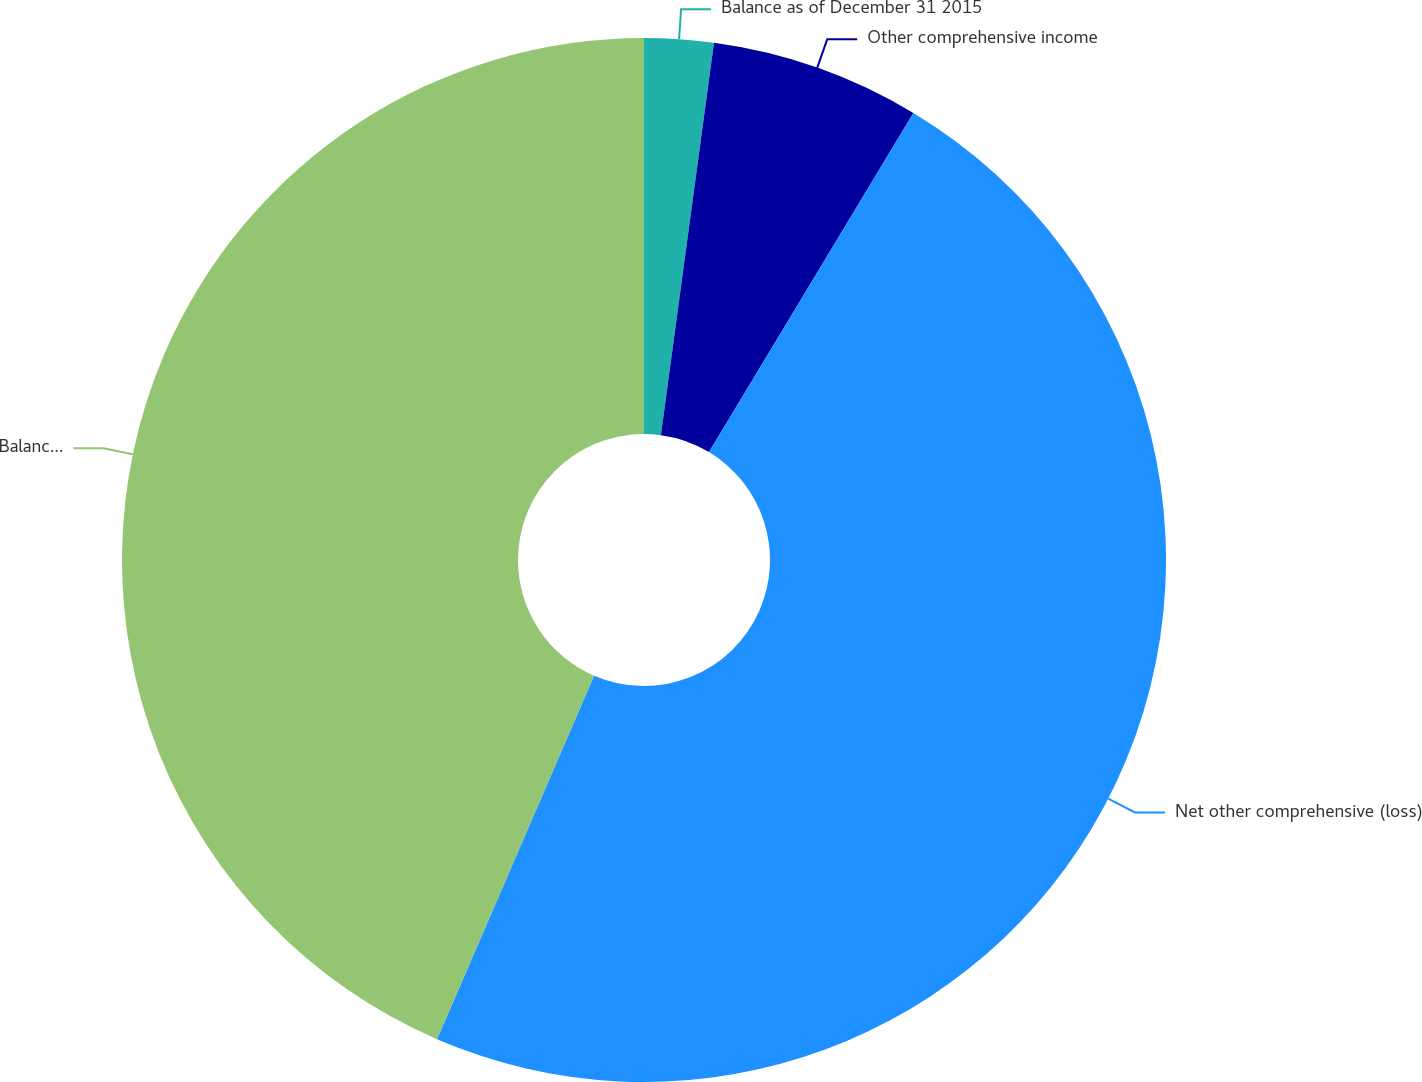Convert chart. <chart><loc_0><loc_0><loc_500><loc_500><pie_chart><fcel>Balance as of December 31 2015<fcel>Other comprehensive income<fcel>Net other comprehensive (loss)<fcel>Balance as of December 31 2016<nl><fcel>2.14%<fcel>6.49%<fcel>47.86%<fcel>43.51%<nl></chart> 